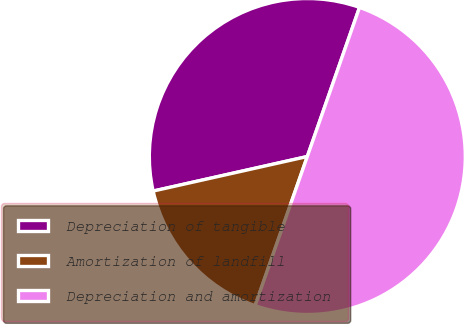Convert chart to OTSL. <chart><loc_0><loc_0><loc_500><loc_500><pie_chart><fcel>Depreciation of tangible<fcel>Amortization of landfill<fcel>Depreciation and amortization<nl><fcel>33.87%<fcel>16.13%<fcel>50.0%<nl></chart> 